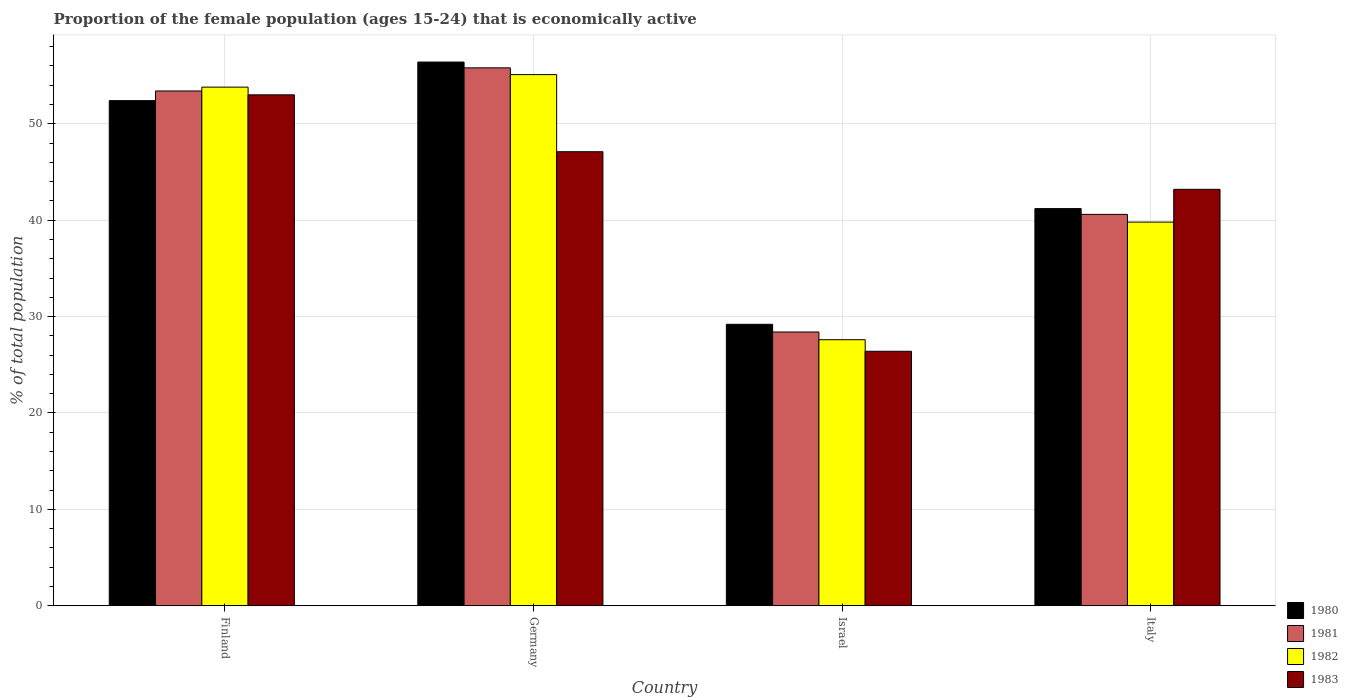How many different coloured bars are there?
Keep it short and to the point. 4. How many groups of bars are there?
Your answer should be compact. 4. How many bars are there on the 4th tick from the left?
Provide a succinct answer. 4. What is the label of the 3rd group of bars from the left?
Provide a short and direct response. Israel. In how many cases, is the number of bars for a given country not equal to the number of legend labels?
Your answer should be very brief. 0. What is the proportion of the female population that is economically active in 1980 in Germany?
Your answer should be compact. 56.4. Across all countries, what is the maximum proportion of the female population that is economically active in 1983?
Offer a very short reply. 53. Across all countries, what is the minimum proportion of the female population that is economically active in 1982?
Offer a very short reply. 27.6. In which country was the proportion of the female population that is economically active in 1981 minimum?
Your response must be concise. Israel. What is the total proportion of the female population that is economically active in 1983 in the graph?
Provide a succinct answer. 169.7. What is the difference between the proportion of the female population that is economically active in 1983 in Finland and that in Germany?
Make the answer very short. 5.9. What is the average proportion of the female population that is economically active in 1982 per country?
Offer a very short reply. 44.07. What is the difference between the proportion of the female population that is economically active of/in 1982 and proportion of the female population that is economically active of/in 1981 in Israel?
Give a very brief answer. -0.8. What is the ratio of the proportion of the female population that is economically active in 1983 in Finland to that in Italy?
Your response must be concise. 1.23. Is the proportion of the female population that is economically active in 1983 in Israel less than that in Italy?
Keep it short and to the point. Yes. Is the difference between the proportion of the female population that is economically active in 1982 in Germany and Italy greater than the difference between the proportion of the female population that is economically active in 1981 in Germany and Italy?
Make the answer very short. Yes. What is the difference between the highest and the second highest proportion of the female population that is economically active in 1983?
Your response must be concise. -9.8. What is the difference between the highest and the lowest proportion of the female population that is economically active in 1980?
Provide a short and direct response. 27.2. Is it the case that in every country, the sum of the proportion of the female population that is economically active in 1982 and proportion of the female population that is economically active in 1981 is greater than the sum of proportion of the female population that is economically active in 1980 and proportion of the female population that is economically active in 1983?
Your answer should be very brief. No. What does the 2nd bar from the left in Finland represents?
Provide a succinct answer. 1981. Is it the case that in every country, the sum of the proportion of the female population that is economically active in 1983 and proportion of the female population that is economically active in 1980 is greater than the proportion of the female population that is economically active in 1981?
Keep it short and to the point. Yes. How many bars are there?
Offer a very short reply. 16. Are all the bars in the graph horizontal?
Ensure brevity in your answer.  No. How many countries are there in the graph?
Your answer should be very brief. 4. What is the difference between two consecutive major ticks on the Y-axis?
Your response must be concise. 10. Are the values on the major ticks of Y-axis written in scientific E-notation?
Your answer should be very brief. No. Does the graph contain any zero values?
Your answer should be very brief. No. Where does the legend appear in the graph?
Provide a short and direct response. Bottom right. How many legend labels are there?
Provide a short and direct response. 4. What is the title of the graph?
Keep it short and to the point. Proportion of the female population (ages 15-24) that is economically active. What is the label or title of the X-axis?
Offer a very short reply. Country. What is the label or title of the Y-axis?
Offer a terse response. % of total population. What is the % of total population in 1980 in Finland?
Keep it short and to the point. 52.4. What is the % of total population in 1981 in Finland?
Make the answer very short. 53.4. What is the % of total population in 1982 in Finland?
Your answer should be compact. 53.8. What is the % of total population in 1983 in Finland?
Your response must be concise. 53. What is the % of total population of 1980 in Germany?
Offer a terse response. 56.4. What is the % of total population of 1981 in Germany?
Provide a short and direct response. 55.8. What is the % of total population of 1982 in Germany?
Give a very brief answer. 55.1. What is the % of total population in 1983 in Germany?
Your answer should be compact. 47.1. What is the % of total population in 1980 in Israel?
Ensure brevity in your answer.  29.2. What is the % of total population in 1981 in Israel?
Your response must be concise. 28.4. What is the % of total population in 1982 in Israel?
Keep it short and to the point. 27.6. What is the % of total population of 1983 in Israel?
Your answer should be very brief. 26.4. What is the % of total population of 1980 in Italy?
Provide a succinct answer. 41.2. What is the % of total population in 1981 in Italy?
Your response must be concise. 40.6. What is the % of total population in 1982 in Italy?
Your answer should be very brief. 39.8. What is the % of total population of 1983 in Italy?
Ensure brevity in your answer.  43.2. Across all countries, what is the maximum % of total population in 1980?
Provide a short and direct response. 56.4. Across all countries, what is the maximum % of total population of 1981?
Ensure brevity in your answer.  55.8. Across all countries, what is the maximum % of total population in 1982?
Offer a very short reply. 55.1. Across all countries, what is the maximum % of total population in 1983?
Your answer should be very brief. 53. Across all countries, what is the minimum % of total population of 1980?
Ensure brevity in your answer.  29.2. Across all countries, what is the minimum % of total population in 1981?
Your response must be concise. 28.4. Across all countries, what is the minimum % of total population in 1982?
Provide a short and direct response. 27.6. Across all countries, what is the minimum % of total population of 1983?
Your answer should be very brief. 26.4. What is the total % of total population of 1980 in the graph?
Make the answer very short. 179.2. What is the total % of total population of 1981 in the graph?
Offer a terse response. 178.2. What is the total % of total population of 1982 in the graph?
Keep it short and to the point. 176.3. What is the total % of total population of 1983 in the graph?
Make the answer very short. 169.7. What is the difference between the % of total population in 1980 in Finland and that in Germany?
Give a very brief answer. -4. What is the difference between the % of total population in 1981 in Finland and that in Germany?
Your response must be concise. -2.4. What is the difference between the % of total population in 1982 in Finland and that in Germany?
Offer a terse response. -1.3. What is the difference between the % of total population in 1980 in Finland and that in Israel?
Ensure brevity in your answer.  23.2. What is the difference between the % of total population of 1981 in Finland and that in Israel?
Give a very brief answer. 25. What is the difference between the % of total population of 1982 in Finland and that in Israel?
Your response must be concise. 26.2. What is the difference between the % of total population of 1983 in Finland and that in Israel?
Make the answer very short. 26.6. What is the difference between the % of total population of 1982 in Finland and that in Italy?
Your response must be concise. 14. What is the difference between the % of total population of 1980 in Germany and that in Israel?
Ensure brevity in your answer.  27.2. What is the difference between the % of total population in 1981 in Germany and that in Israel?
Offer a very short reply. 27.4. What is the difference between the % of total population in 1982 in Germany and that in Israel?
Make the answer very short. 27.5. What is the difference between the % of total population of 1983 in Germany and that in Israel?
Keep it short and to the point. 20.7. What is the difference between the % of total population of 1980 in Germany and that in Italy?
Provide a short and direct response. 15.2. What is the difference between the % of total population of 1981 in Israel and that in Italy?
Ensure brevity in your answer.  -12.2. What is the difference between the % of total population in 1983 in Israel and that in Italy?
Provide a succinct answer. -16.8. What is the difference between the % of total population in 1980 in Finland and the % of total population in 1981 in Germany?
Keep it short and to the point. -3.4. What is the difference between the % of total population in 1980 in Finland and the % of total population in 1982 in Germany?
Ensure brevity in your answer.  -2.7. What is the difference between the % of total population in 1981 in Finland and the % of total population in 1982 in Germany?
Provide a succinct answer. -1.7. What is the difference between the % of total population in 1981 in Finland and the % of total population in 1983 in Germany?
Make the answer very short. 6.3. What is the difference between the % of total population of 1980 in Finland and the % of total population of 1981 in Israel?
Your answer should be compact. 24. What is the difference between the % of total population in 1980 in Finland and the % of total population in 1982 in Israel?
Your answer should be very brief. 24.8. What is the difference between the % of total population of 1980 in Finland and the % of total population of 1983 in Israel?
Keep it short and to the point. 26. What is the difference between the % of total population in 1981 in Finland and the % of total population in 1982 in Israel?
Provide a succinct answer. 25.8. What is the difference between the % of total population in 1982 in Finland and the % of total population in 1983 in Israel?
Ensure brevity in your answer.  27.4. What is the difference between the % of total population in 1980 in Finland and the % of total population in 1982 in Italy?
Your response must be concise. 12.6. What is the difference between the % of total population of 1981 in Finland and the % of total population of 1983 in Italy?
Provide a short and direct response. 10.2. What is the difference between the % of total population of 1980 in Germany and the % of total population of 1981 in Israel?
Your answer should be very brief. 28. What is the difference between the % of total population of 1980 in Germany and the % of total population of 1982 in Israel?
Make the answer very short. 28.8. What is the difference between the % of total population of 1981 in Germany and the % of total population of 1982 in Israel?
Give a very brief answer. 28.2. What is the difference between the % of total population in 1981 in Germany and the % of total population in 1983 in Israel?
Your response must be concise. 29.4. What is the difference between the % of total population of 1982 in Germany and the % of total population of 1983 in Israel?
Ensure brevity in your answer.  28.7. What is the difference between the % of total population of 1980 in Germany and the % of total population of 1981 in Italy?
Provide a short and direct response. 15.8. What is the difference between the % of total population of 1980 in Germany and the % of total population of 1982 in Italy?
Give a very brief answer. 16.6. What is the difference between the % of total population of 1981 in Germany and the % of total population of 1982 in Italy?
Offer a terse response. 16. What is the difference between the % of total population in 1980 in Israel and the % of total population in 1981 in Italy?
Keep it short and to the point. -11.4. What is the difference between the % of total population of 1980 in Israel and the % of total population of 1983 in Italy?
Make the answer very short. -14. What is the difference between the % of total population of 1981 in Israel and the % of total population of 1983 in Italy?
Provide a short and direct response. -14.8. What is the difference between the % of total population of 1982 in Israel and the % of total population of 1983 in Italy?
Your answer should be very brief. -15.6. What is the average % of total population in 1980 per country?
Offer a very short reply. 44.8. What is the average % of total population in 1981 per country?
Your answer should be compact. 44.55. What is the average % of total population of 1982 per country?
Your answer should be very brief. 44.08. What is the average % of total population in 1983 per country?
Provide a succinct answer. 42.42. What is the difference between the % of total population in 1980 and % of total population in 1981 in Finland?
Provide a succinct answer. -1. What is the difference between the % of total population of 1980 and % of total population of 1982 in Finland?
Keep it short and to the point. -1.4. What is the difference between the % of total population of 1980 and % of total population of 1983 in Finland?
Provide a succinct answer. -0.6. What is the difference between the % of total population in 1981 and % of total population in 1983 in Finland?
Offer a terse response. 0.4. What is the difference between the % of total population of 1982 and % of total population of 1983 in Finland?
Keep it short and to the point. 0.8. What is the difference between the % of total population of 1980 and % of total population of 1981 in Germany?
Offer a very short reply. 0.6. What is the difference between the % of total population of 1981 and % of total population of 1982 in Germany?
Your answer should be very brief. 0.7. What is the difference between the % of total population in 1981 and % of total population in 1983 in Germany?
Make the answer very short. 8.7. What is the difference between the % of total population of 1980 and % of total population of 1981 in Israel?
Provide a succinct answer. 0.8. What is the difference between the % of total population in 1980 and % of total population in 1982 in Israel?
Give a very brief answer. 1.6. What is the difference between the % of total population of 1981 and % of total population of 1983 in Israel?
Keep it short and to the point. 2. What is the difference between the % of total population in 1980 and % of total population in 1982 in Italy?
Ensure brevity in your answer.  1.4. What is the difference between the % of total population of 1980 and % of total population of 1983 in Italy?
Make the answer very short. -2. What is the difference between the % of total population of 1981 and % of total population of 1982 in Italy?
Make the answer very short. 0.8. What is the ratio of the % of total population in 1980 in Finland to that in Germany?
Give a very brief answer. 0.93. What is the ratio of the % of total population of 1981 in Finland to that in Germany?
Give a very brief answer. 0.96. What is the ratio of the % of total population in 1982 in Finland to that in Germany?
Your answer should be very brief. 0.98. What is the ratio of the % of total population in 1983 in Finland to that in Germany?
Provide a succinct answer. 1.13. What is the ratio of the % of total population of 1980 in Finland to that in Israel?
Provide a short and direct response. 1.79. What is the ratio of the % of total population in 1981 in Finland to that in Israel?
Your response must be concise. 1.88. What is the ratio of the % of total population in 1982 in Finland to that in Israel?
Provide a succinct answer. 1.95. What is the ratio of the % of total population in 1983 in Finland to that in Israel?
Offer a terse response. 2.01. What is the ratio of the % of total population in 1980 in Finland to that in Italy?
Ensure brevity in your answer.  1.27. What is the ratio of the % of total population of 1981 in Finland to that in Italy?
Provide a succinct answer. 1.32. What is the ratio of the % of total population of 1982 in Finland to that in Italy?
Provide a succinct answer. 1.35. What is the ratio of the % of total population of 1983 in Finland to that in Italy?
Provide a succinct answer. 1.23. What is the ratio of the % of total population in 1980 in Germany to that in Israel?
Your response must be concise. 1.93. What is the ratio of the % of total population in 1981 in Germany to that in Israel?
Give a very brief answer. 1.96. What is the ratio of the % of total population in 1982 in Germany to that in Israel?
Give a very brief answer. 2. What is the ratio of the % of total population of 1983 in Germany to that in Israel?
Offer a terse response. 1.78. What is the ratio of the % of total population in 1980 in Germany to that in Italy?
Offer a very short reply. 1.37. What is the ratio of the % of total population in 1981 in Germany to that in Italy?
Offer a very short reply. 1.37. What is the ratio of the % of total population of 1982 in Germany to that in Italy?
Your answer should be compact. 1.38. What is the ratio of the % of total population in 1983 in Germany to that in Italy?
Your answer should be very brief. 1.09. What is the ratio of the % of total population in 1980 in Israel to that in Italy?
Keep it short and to the point. 0.71. What is the ratio of the % of total population of 1981 in Israel to that in Italy?
Make the answer very short. 0.7. What is the ratio of the % of total population in 1982 in Israel to that in Italy?
Provide a succinct answer. 0.69. What is the ratio of the % of total population of 1983 in Israel to that in Italy?
Ensure brevity in your answer.  0.61. What is the difference between the highest and the second highest % of total population in 1980?
Keep it short and to the point. 4. What is the difference between the highest and the lowest % of total population of 1980?
Your response must be concise. 27.2. What is the difference between the highest and the lowest % of total population in 1981?
Give a very brief answer. 27.4. What is the difference between the highest and the lowest % of total population in 1982?
Offer a terse response. 27.5. What is the difference between the highest and the lowest % of total population in 1983?
Provide a succinct answer. 26.6. 